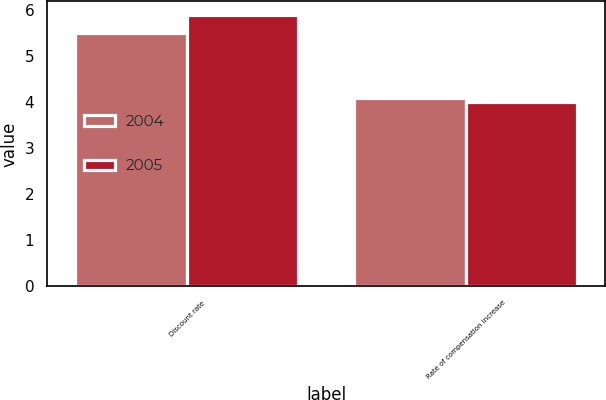Convert chart to OTSL. <chart><loc_0><loc_0><loc_500><loc_500><stacked_bar_chart><ecel><fcel>Discount rate<fcel>Rate of compensation increase<nl><fcel>2004<fcel>5.5<fcel>4.1<nl><fcel>2005<fcel>5.9<fcel>4<nl></chart> 